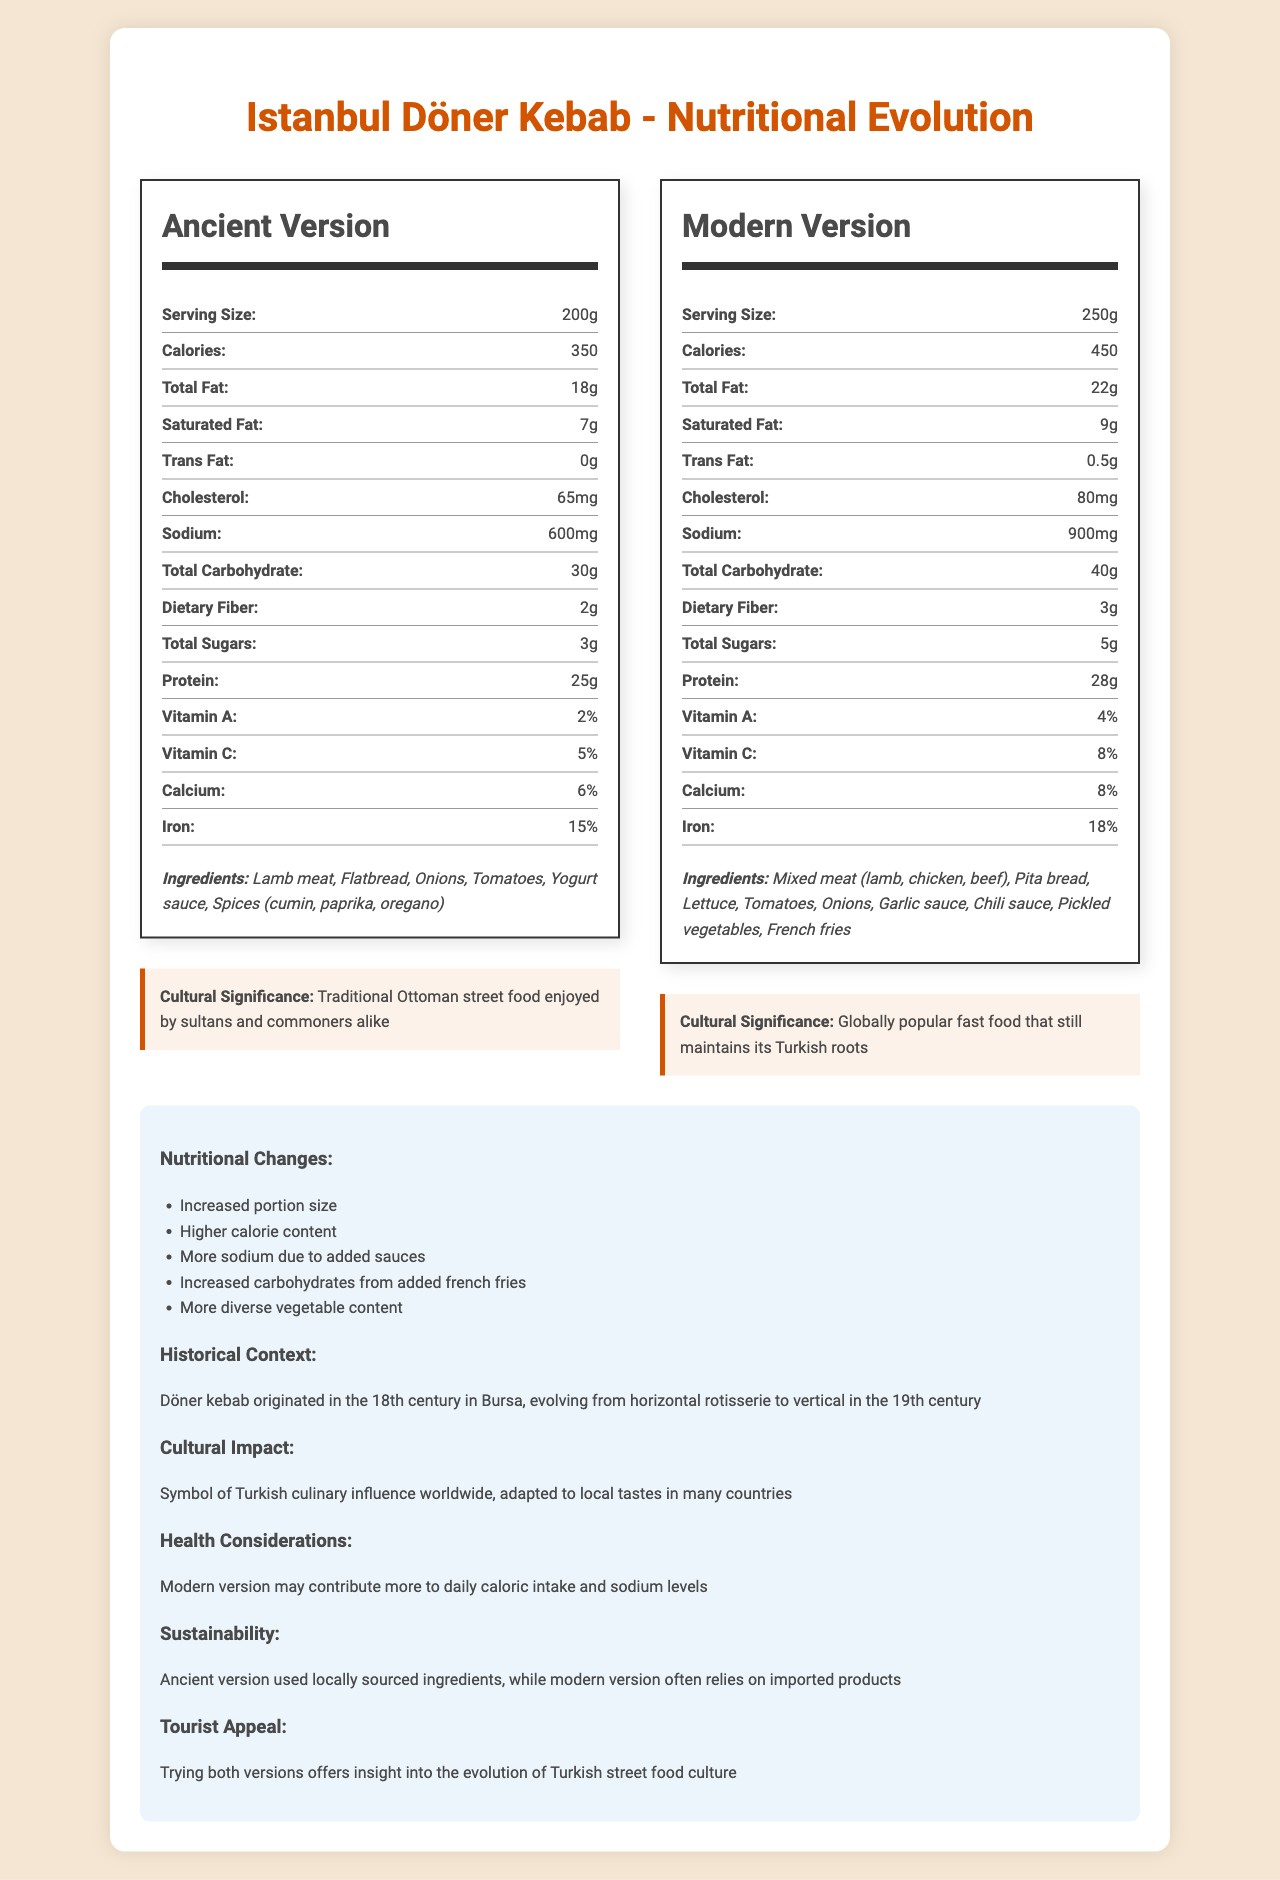what city is the food item from? The document clearly states that the city is Istanbul.
Answer: Istanbul What is the serving size of the ancient version of the Döner Kebab? The document lists the serving size of the ancient version as 200g.
Answer: 200g What are the ingredients in the modern version of the Döner Kebab? The ingredient list for the modern version is provided in the document.
Answer: Mixed meat (lamb, chicken, beef), Pita bread, Lettuce, Tomatoes, Onions, Garlic sauce, Chili sauce, Pickled vegetables, French fries How many calories does the modern version of the Döner Kebab have? The document specifies that the modern version has 450 calories.
Answer: 450 By how much has the sodium content increased from the ancient to the modern version? The sodium content in the ancient version is 600mg, and in the modern version, it is 900mg. The increase is 300mg.
Answer: 300mg What traditional street food's cultural significance is enjoyed by both sultans and commoners alike? The cultural significance of the ancient version mentions that it was enjoyed by sultans and commoners alike.
Answer: Döner Kebab What is one of the health considerations to keep in mind about the modern version of Döner Kebab? The document mentions that the modern version may contribute more to daily caloric intake and sodium levels.
Answer: Contributes more to daily caloric intake and sodium levels Which version of the Döner Kebab uses locally sourced ingredients more frequently? A. Ancient version B. Modern version C. Both equally The document states that the ancient version used locally sourced ingredients, while the modern version often relies on imported products.
Answer: A. Ancient version Which nutrient's percentage is higher in the modern version compared to the ancient version? A. Vitamin A B. Calcium C. Dietary fiber D. Total Sugars The total sugars content in the modern version is 5g, whereas in the ancient version it is 3g, indicating an increase.
Answer: D. Total Sugars Is the modern version of Döner Kebab more diverse in vegetable content than the ancient version? The document lists more diverse vegetable ingredients in the modern version, including lettuce and pickled vegetables, which are not mentioned in the ancient version.
Answer: Yes Describe the main idea of the document. The document provides a thorough comparison between the ancient and modern versions of Döner Kebab, focusing on nutritional data, ingredient lists, cultural significance, and health considerations, alongside historical and cultural context.
Answer: The document compares the nutritional facts and cultural significance of the ancient and modern versions of Döner Kebab from Istanbul. It highlights differences in serving size, calorie content, ingredients, and health considerations. The document also discusses the historical evolution and global cultural impact of Döner Kebab. What was the origin city of Döner Kebab? The document mentions that Döner Kebab originated in the 18th century in Bursa.
Answer: Bursa How does the portion size of the modern version compare to the ancient version? The ancient version has a serving size of 200g, while the modern version has a serving size of 250g.
Answer: The modern version's portion size is 50g larger than the ancient version Which version of Döner Kebab includes french fries as an ingredient? The ingredient list of the modern version includes french fries, not present in the ancient version.
Answer: Modern version What percentage of Vitamin C is available in the modern version of Döner Kebab? The nutritional facts indicate that the modern version contains 8% Vitamin C.
Answer: 8% What nutritional content cannot be determined from the document? The document provides total dietary fiber content but does not specify whether it is soluble or insoluble fiber.
Answer: Fiber type (soluble or insoluble) 